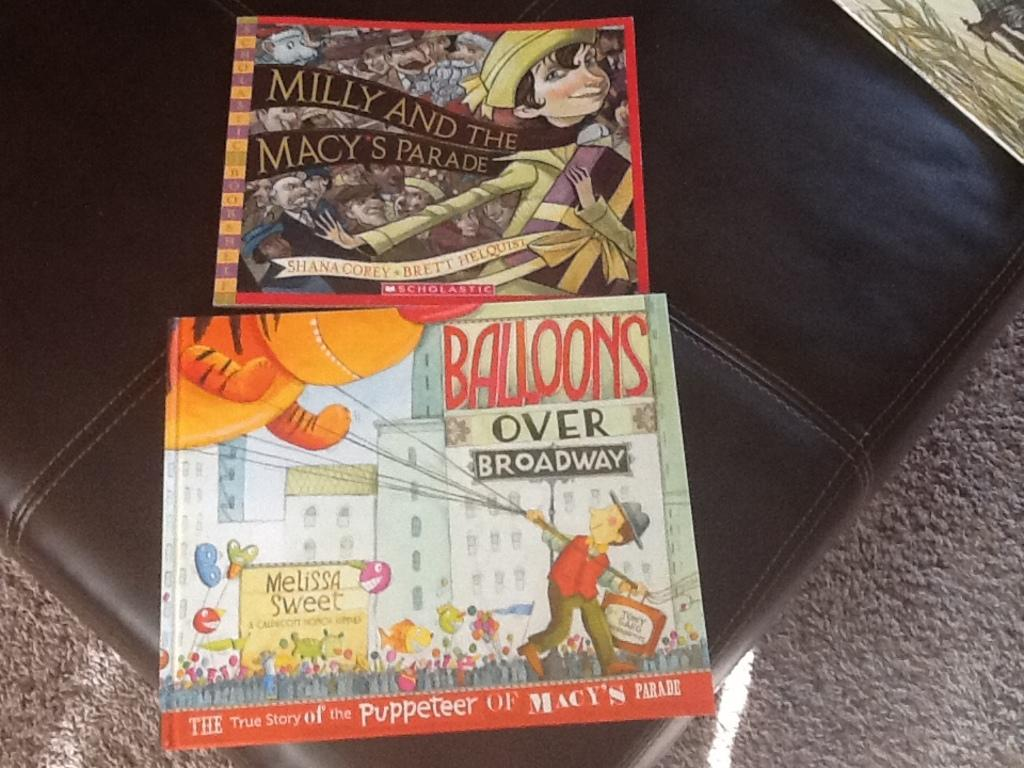<image>
Share a concise interpretation of the image provided. Two covers one that says Milly and the Macy's Parade on it. 